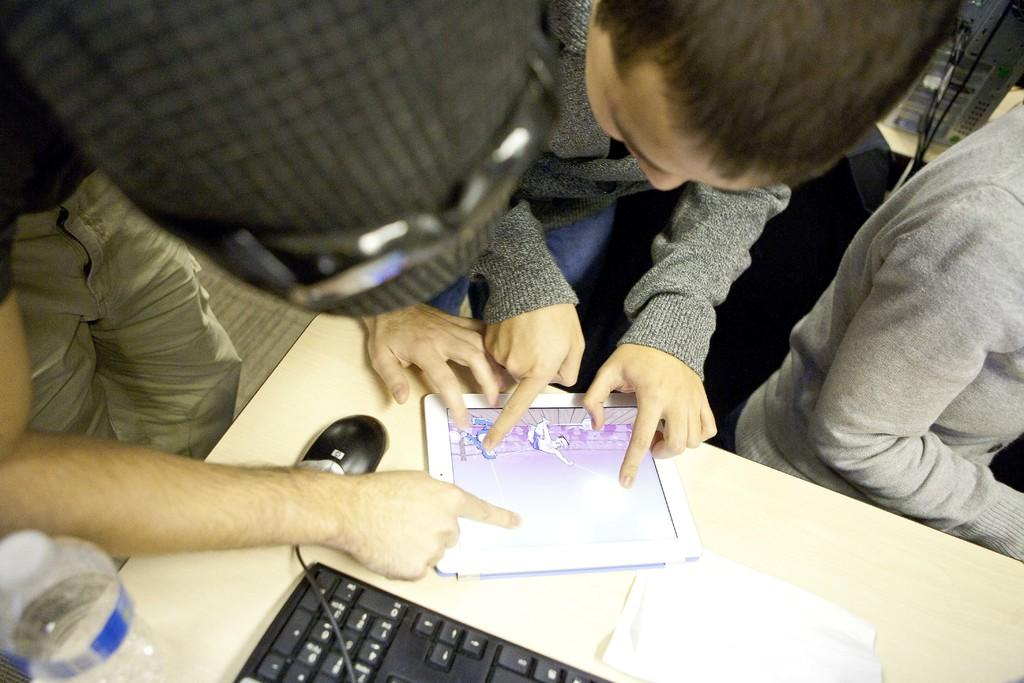How many people are in the image? There are people in the image, but the exact number is not specified. What objects can be seen on the table in the image? There is a gadget, a mouse, a bottle, a cable, and a paper on the table in the image. What is the device visible in the background of the image? The device visible in the background of the image is not specified. Is there a chain attached to the mouse in the image? No, there is no chain attached to the mouse in the image. Can you see a spring on the device in the background of the image? The facts do not mention a spring, so it is not possible to determine if there is one on the device in the background. 